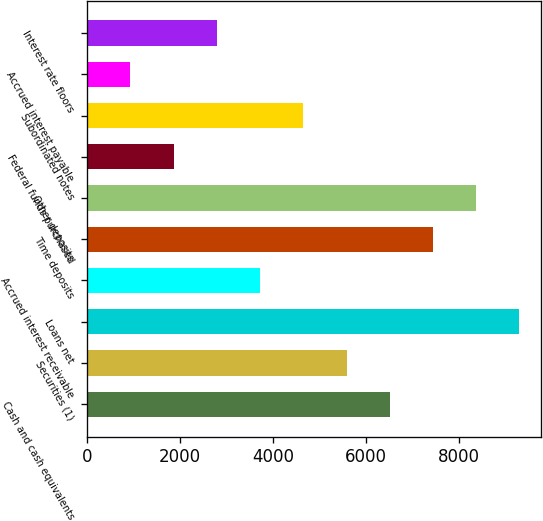Convert chart. <chart><loc_0><loc_0><loc_500><loc_500><bar_chart><fcel>Cash and cash equivalents<fcel>Securities (1)<fcel>Loans net<fcel>Accrued interest receivable<fcel>Time deposits<fcel>Other deposits<fcel>Federal funds purchased<fcel>Subordinated notes<fcel>Accrued interest payable<fcel>Interest rate floors<nl><fcel>6508.45<fcel>5578.7<fcel>9297.7<fcel>3719.2<fcel>7438.2<fcel>8367.95<fcel>1859.7<fcel>4648.95<fcel>929.95<fcel>2789.45<nl></chart> 